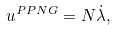<formula> <loc_0><loc_0><loc_500><loc_500>u ^ { \mathit P P N G } = N \dot { \lambda } ,</formula> 